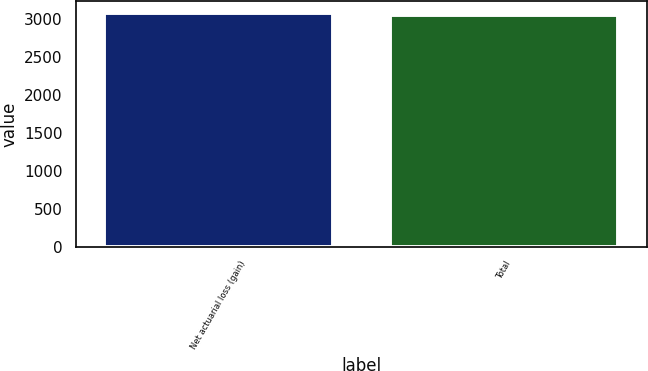<chart> <loc_0><loc_0><loc_500><loc_500><bar_chart><fcel>Net actuarial loss (gain)<fcel>Total<nl><fcel>3080<fcel>3051<nl></chart> 